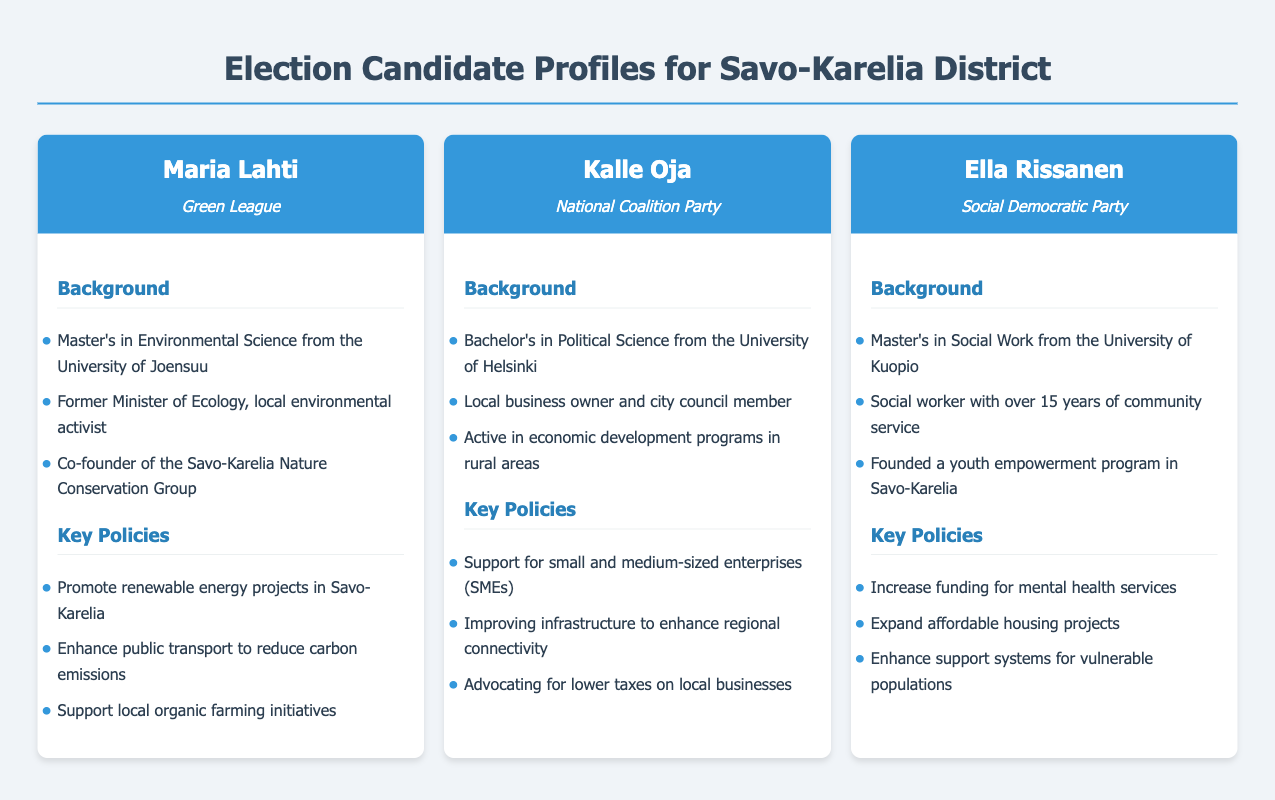What is Maria Lahti's party affiliation? Maria Lahti is affiliated with the Green League, as stated in the candidate profile.
Answer: Green League What is Kalle Oja's educational background? Kalle Oja holds a Bachelor's in Political Science from the University of Helsinki, which is mentioned in his background.
Answer: Bachelor's in Political Science How many years of community service does Ella Rissanen have? Ella Rissanen has over 15 years of community service, as noted in her profile.
Answer: 15 years Which candidate supports renewable energy projects? The document mentions that Maria Lahti promotes renewable energy projects in Savo-Karelia.
Answer: Maria Lahti What policy does Kalle Oja advocate regarding local businesses? Kalle Oja advocates for lower taxes on local businesses, as listed in his key policies.
Answer: Lower taxes Which candidate founded a youth empowerment program? Ella Rissanen is noted as having founded a youth empowerment program in Savo-Karelia.
Answer: Ella Rissanen What is a key policy of Maria Lahti? One of her key policies is to enhance public transport to reduce carbon emissions.
Answer: Enhance public transport Who is a former Minister of Ecology? The document indicates that Maria Lahti was a former Minister of Ecology.
Answer: Maria Lahti What topic does Ella Rissanen focus on regarding vulnerable populations? Ella Rissanen's focus is on enhancing support systems for vulnerable populations.
Answer: Support systems 